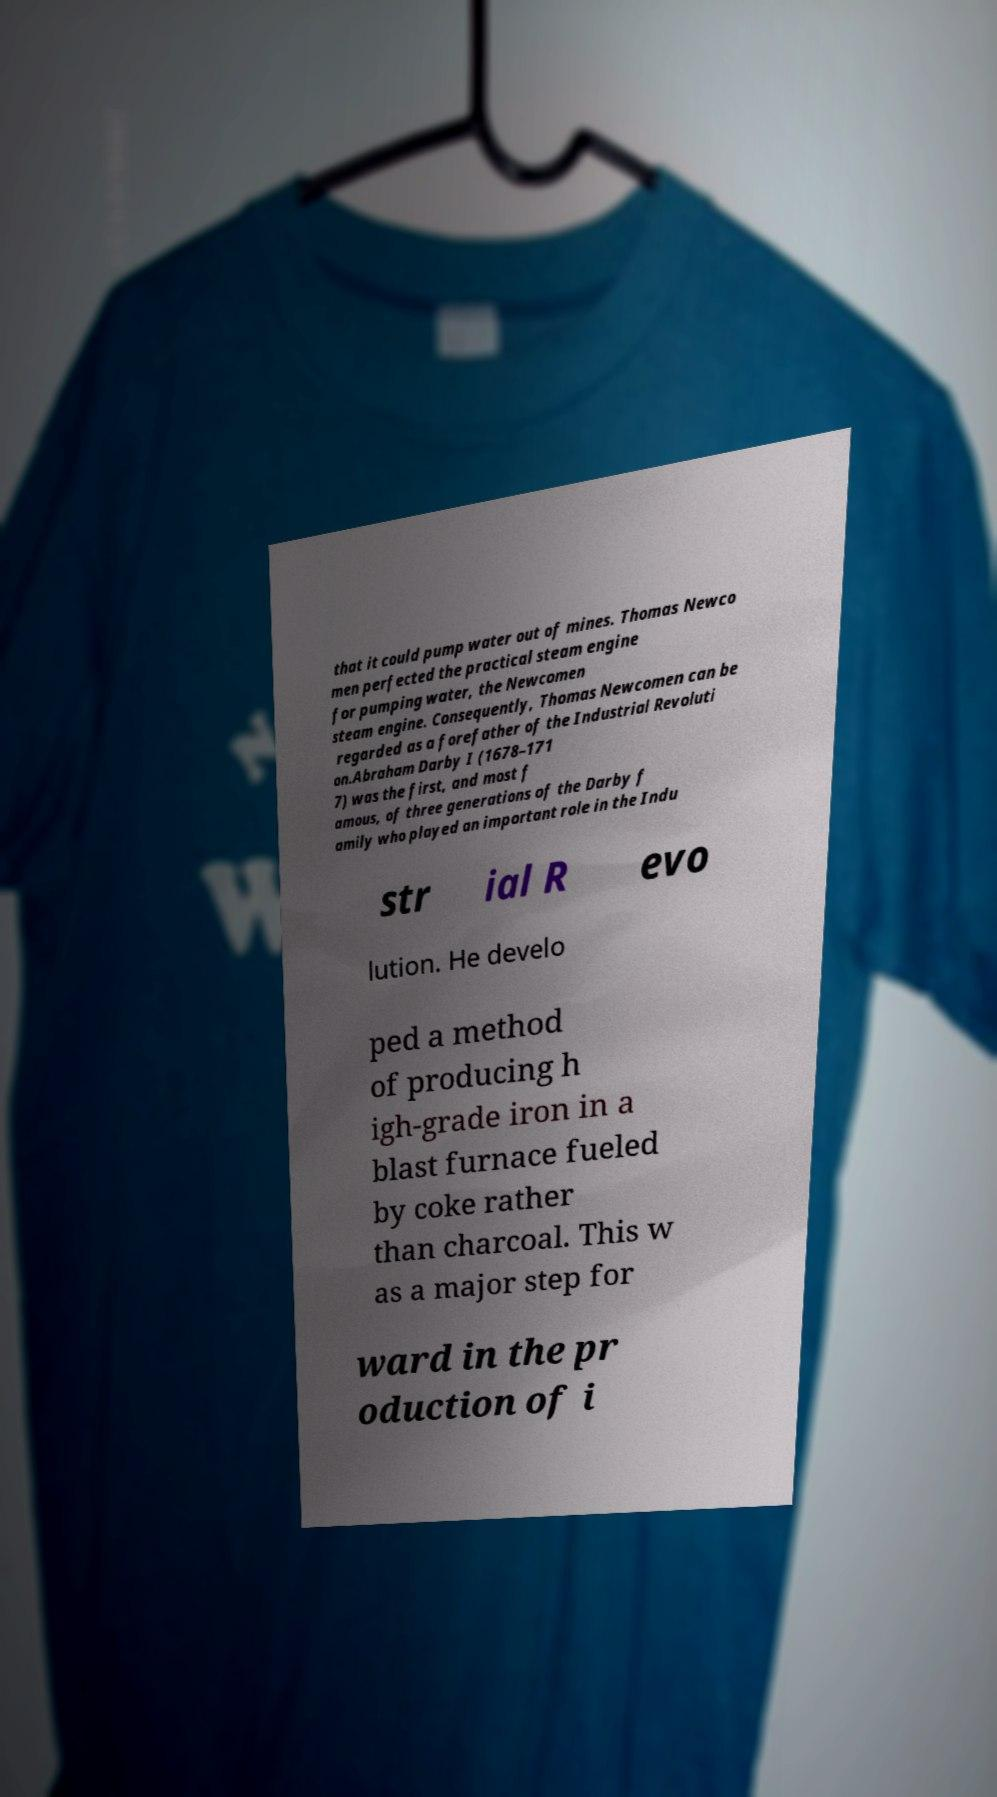Could you extract and type out the text from this image? that it could pump water out of mines. Thomas Newco men perfected the practical steam engine for pumping water, the Newcomen steam engine. Consequently, Thomas Newcomen can be regarded as a forefather of the Industrial Revoluti on.Abraham Darby I (1678–171 7) was the first, and most f amous, of three generations of the Darby f amily who played an important role in the Indu str ial R evo lution. He develo ped a method of producing h igh-grade iron in a blast furnace fueled by coke rather than charcoal. This w as a major step for ward in the pr oduction of i 